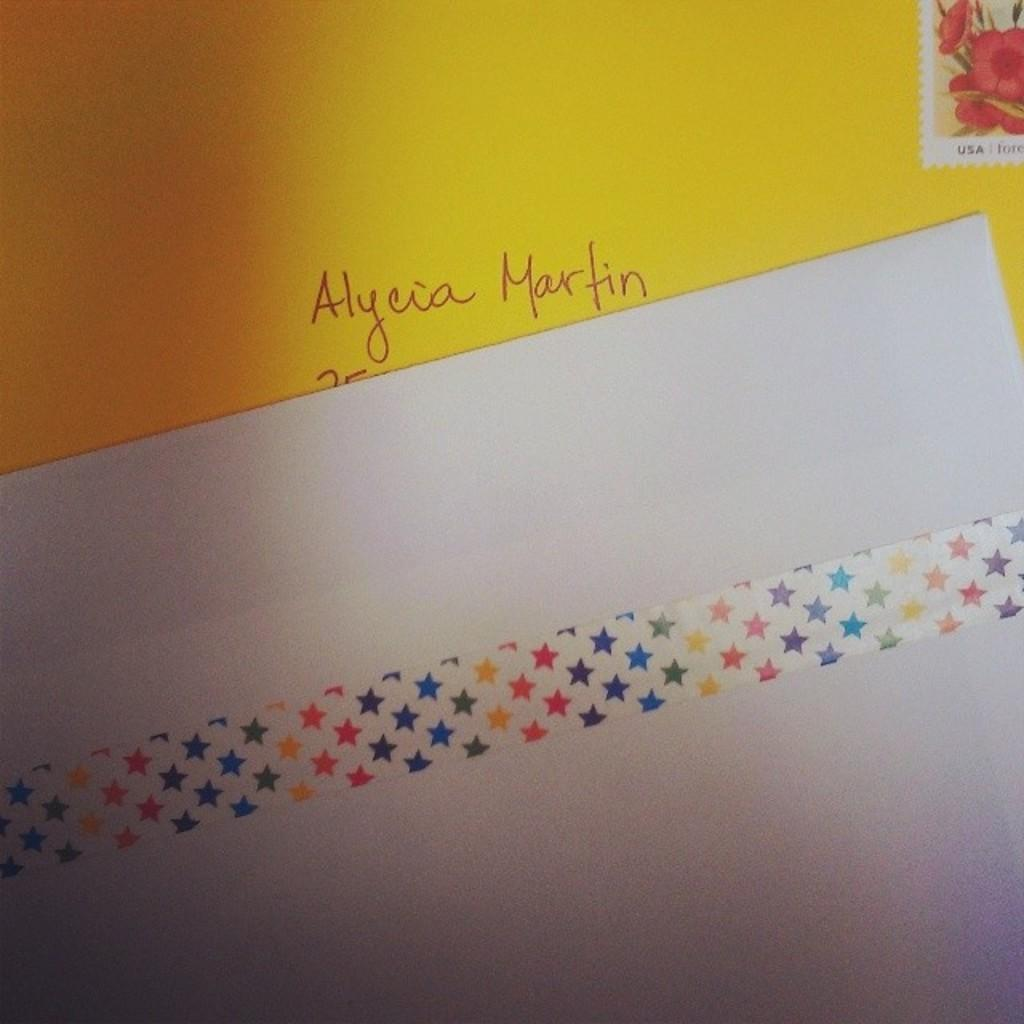<image>
Present a compact description of the photo's key features. A yellow envelope addressed to Alycia Martin with a white paper with stars covering it. 